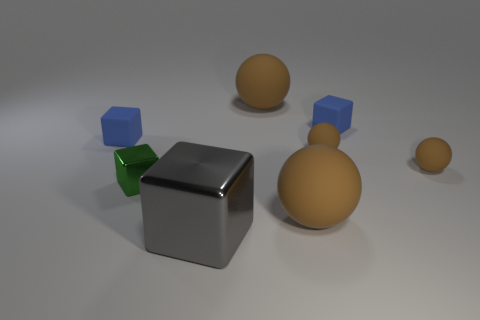Is the number of gray metal cubes less than the number of tiny cyan objects?
Ensure brevity in your answer.  No. Do the gray shiny object on the right side of the green cube and the tiny blue rubber object on the left side of the large gray shiny block have the same shape?
Your answer should be very brief. Yes. The big shiny block is what color?
Give a very brief answer. Gray. What number of metal objects are tiny cubes or tiny green objects?
Keep it short and to the point. 1. There is a tiny metal thing that is the same shape as the large metal object; what is its color?
Offer a terse response. Green. Are there any gray blocks?
Provide a succinct answer. Yes. Is the small blue block that is on the right side of the tiny green metallic thing made of the same material as the small blue thing to the left of the large gray metal object?
Provide a succinct answer. Yes. What number of things are either blue things that are left of the small green metal object or tiny matte blocks on the left side of the big metal cube?
Make the answer very short. 1. Does the big rubber object in front of the tiny green thing have the same color as the small rubber object to the left of the big block?
Your answer should be compact. No. What shape is the big object that is both behind the big metallic cube and in front of the tiny green cube?
Provide a succinct answer. Sphere. 